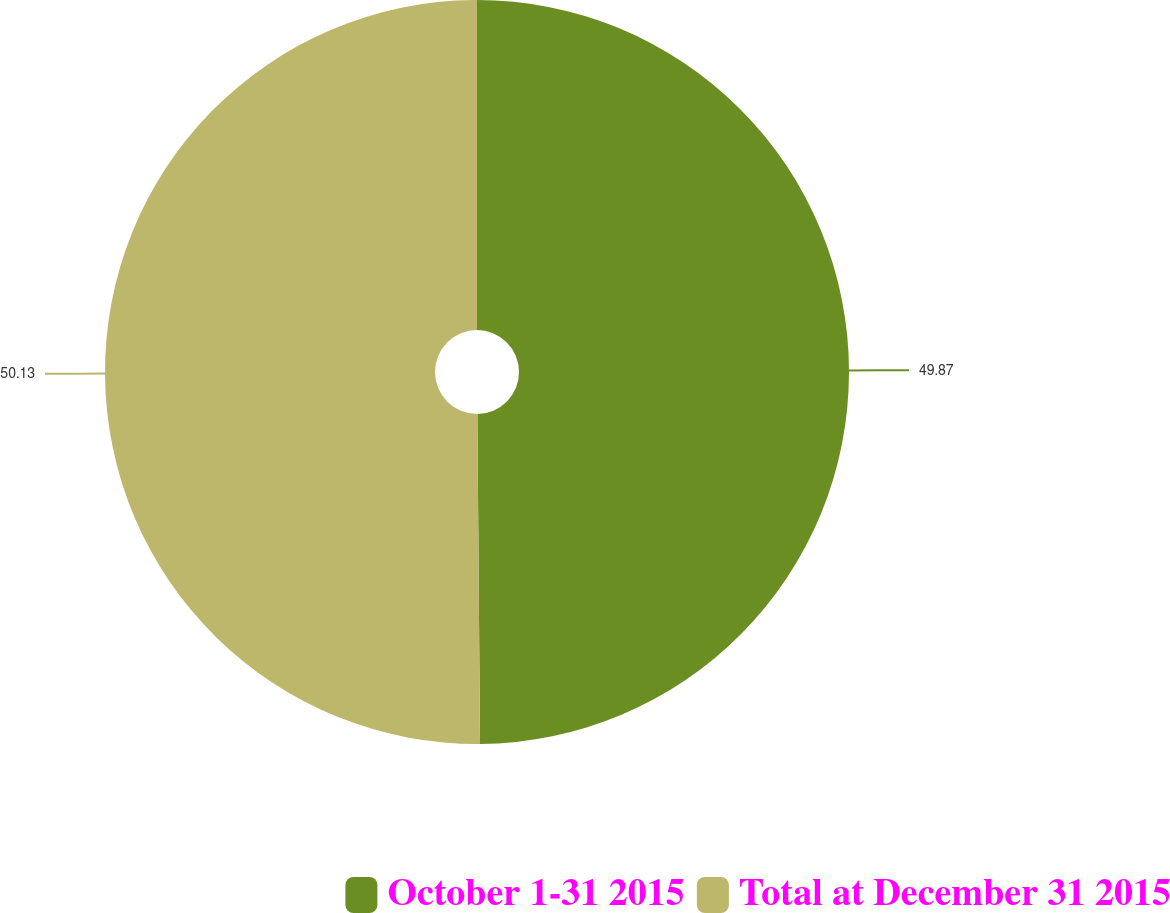Convert chart. <chart><loc_0><loc_0><loc_500><loc_500><pie_chart><fcel>October 1-31 2015<fcel>Total at December 31 2015<nl><fcel>49.87%<fcel>50.13%<nl></chart> 